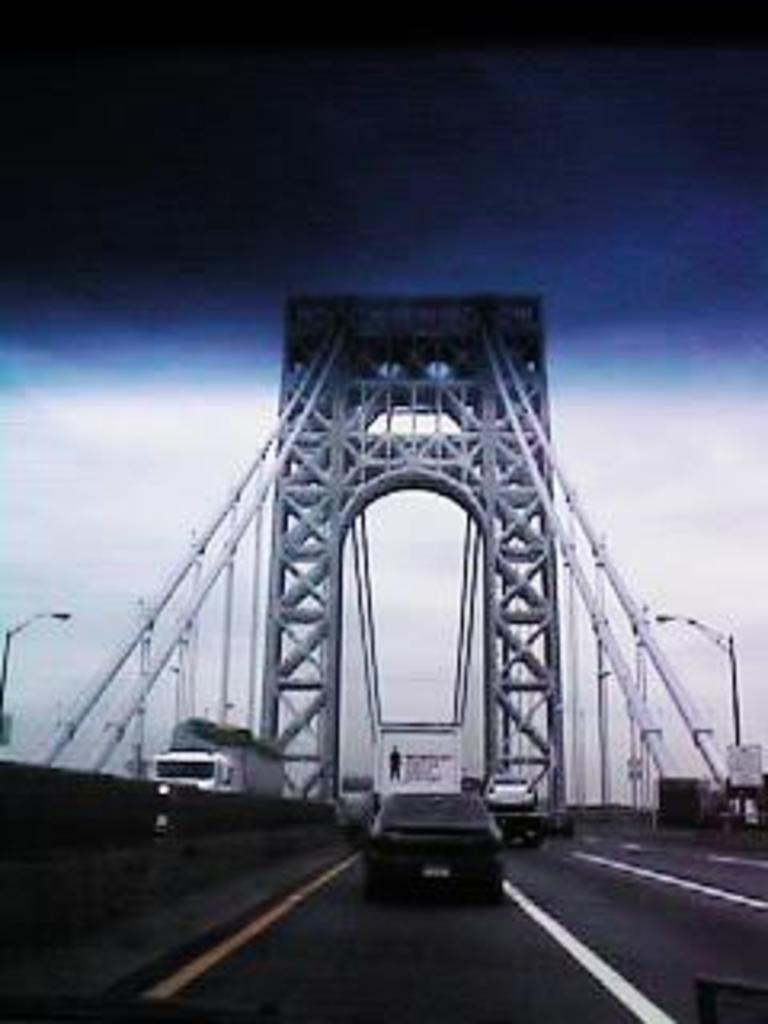What can be seen moving on the road in the image? There are vehicles on the road in the image. What type of structures are present in the image? There are rods, light poles, and boards in the image. What architectural feature is visible in the image? There is an arch in the image. What is visible in the background of the image? The sky is visible in the background of the image. What type of quilt is being used to cover the vehicles in the image? There is no quilt present in the image; it features vehicles on the road, rods, light poles, boards, an arch, and the sky in the background. What advice can be given to the light poles in the image? The light poles in the image are inanimate objects and cannot receive advice. 